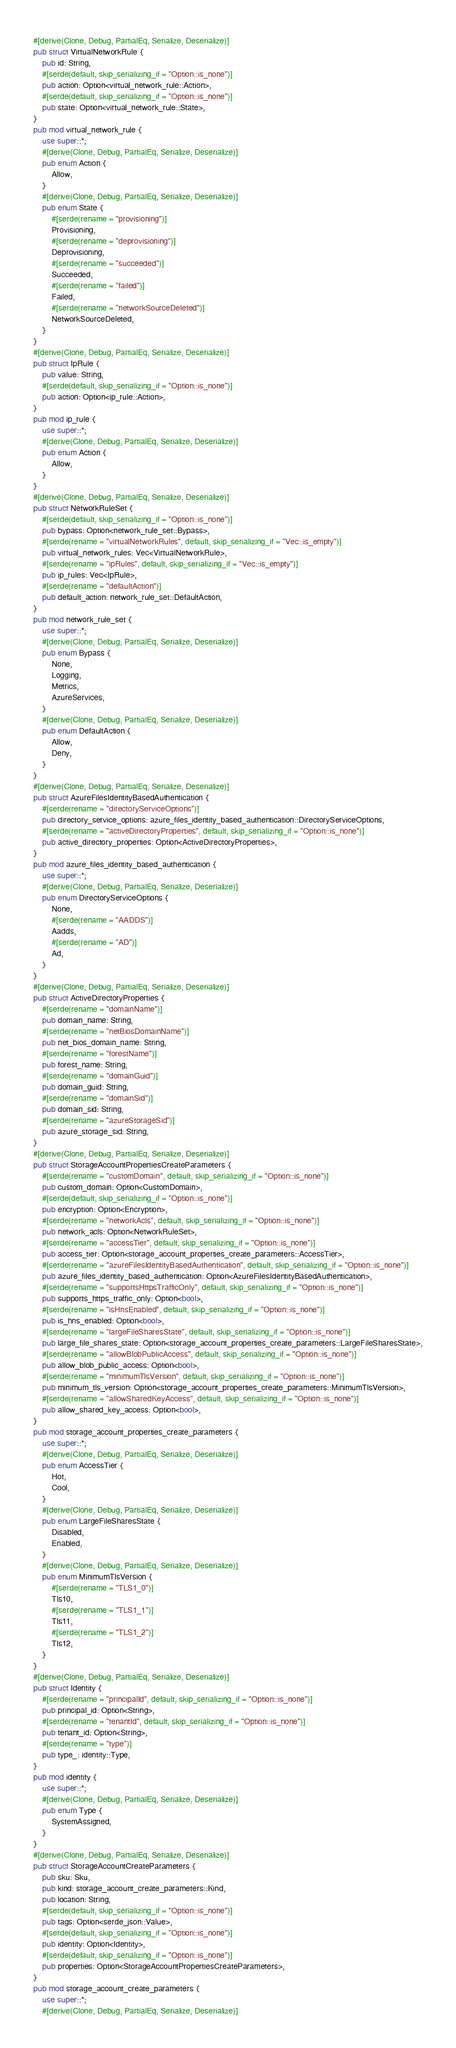Convert code to text. <code><loc_0><loc_0><loc_500><loc_500><_Rust_>#[derive(Clone, Debug, PartialEq, Serialize, Deserialize)]
pub struct VirtualNetworkRule {
    pub id: String,
    #[serde(default, skip_serializing_if = "Option::is_none")]
    pub action: Option<virtual_network_rule::Action>,
    #[serde(default, skip_serializing_if = "Option::is_none")]
    pub state: Option<virtual_network_rule::State>,
}
pub mod virtual_network_rule {
    use super::*;
    #[derive(Clone, Debug, PartialEq, Serialize, Deserialize)]
    pub enum Action {
        Allow,
    }
    #[derive(Clone, Debug, PartialEq, Serialize, Deserialize)]
    pub enum State {
        #[serde(rename = "provisioning")]
        Provisioning,
        #[serde(rename = "deprovisioning")]
        Deprovisioning,
        #[serde(rename = "succeeded")]
        Succeeded,
        #[serde(rename = "failed")]
        Failed,
        #[serde(rename = "networkSourceDeleted")]
        NetworkSourceDeleted,
    }
}
#[derive(Clone, Debug, PartialEq, Serialize, Deserialize)]
pub struct IpRule {
    pub value: String,
    #[serde(default, skip_serializing_if = "Option::is_none")]
    pub action: Option<ip_rule::Action>,
}
pub mod ip_rule {
    use super::*;
    #[derive(Clone, Debug, PartialEq, Serialize, Deserialize)]
    pub enum Action {
        Allow,
    }
}
#[derive(Clone, Debug, PartialEq, Serialize, Deserialize)]
pub struct NetworkRuleSet {
    #[serde(default, skip_serializing_if = "Option::is_none")]
    pub bypass: Option<network_rule_set::Bypass>,
    #[serde(rename = "virtualNetworkRules", default, skip_serializing_if = "Vec::is_empty")]
    pub virtual_network_rules: Vec<VirtualNetworkRule>,
    #[serde(rename = "ipRules", default, skip_serializing_if = "Vec::is_empty")]
    pub ip_rules: Vec<IpRule>,
    #[serde(rename = "defaultAction")]
    pub default_action: network_rule_set::DefaultAction,
}
pub mod network_rule_set {
    use super::*;
    #[derive(Clone, Debug, PartialEq, Serialize, Deserialize)]
    pub enum Bypass {
        None,
        Logging,
        Metrics,
        AzureServices,
    }
    #[derive(Clone, Debug, PartialEq, Serialize, Deserialize)]
    pub enum DefaultAction {
        Allow,
        Deny,
    }
}
#[derive(Clone, Debug, PartialEq, Serialize, Deserialize)]
pub struct AzureFilesIdentityBasedAuthentication {
    #[serde(rename = "directoryServiceOptions")]
    pub directory_service_options: azure_files_identity_based_authentication::DirectoryServiceOptions,
    #[serde(rename = "activeDirectoryProperties", default, skip_serializing_if = "Option::is_none")]
    pub active_directory_properties: Option<ActiveDirectoryProperties>,
}
pub mod azure_files_identity_based_authentication {
    use super::*;
    #[derive(Clone, Debug, PartialEq, Serialize, Deserialize)]
    pub enum DirectoryServiceOptions {
        None,
        #[serde(rename = "AADDS")]
        Aadds,
        #[serde(rename = "AD")]
        Ad,
    }
}
#[derive(Clone, Debug, PartialEq, Serialize, Deserialize)]
pub struct ActiveDirectoryProperties {
    #[serde(rename = "domainName")]
    pub domain_name: String,
    #[serde(rename = "netBiosDomainName")]
    pub net_bios_domain_name: String,
    #[serde(rename = "forestName")]
    pub forest_name: String,
    #[serde(rename = "domainGuid")]
    pub domain_guid: String,
    #[serde(rename = "domainSid")]
    pub domain_sid: String,
    #[serde(rename = "azureStorageSid")]
    pub azure_storage_sid: String,
}
#[derive(Clone, Debug, PartialEq, Serialize, Deserialize)]
pub struct StorageAccountPropertiesCreateParameters {
    #[serde(rename = "customDomain", default, skip_serializing_if = "Option::is_none")]
    pub custom_domain: Option<CustomDomain>,
    #[serde(default, skip_serializing_if = "Option::is_none")]
    pub encryption: Option<Encryption>,
    #[serde(rename = "networkAcls", default, skip_serializing_if = "Option::is_none")]
    pub network_acls: Option<NetworkRuleSet>,
    #[serde(rename = "accessTier", default, skip_serializing_if = "Option::is_none")]
    pub access_tier: Option<storage_account_properties_create_parameters::AccessTier>,
    #[serde(rename = "azureFilesIdentityBasedAuthentication", default, skip_serializing_if = "Option::is_none")]
    pub azure_files_identity_based_authentication: Option<AzureFilesIdentityBasedAuthentication>,
    #[serde(rename = "supportsHttpsTrafficOnly", default, skip_serializing_if = "Option::is_none")]
    pub supports_https_traffic_only: Option<bool>,
    #[serde(rename = "isHnsEnabled", default, skip_serializing_if = "Option::is_none")]
    pub is_hns_enabled: Option<bool>,
    #[serde(rename = "largeFileSharesState", default, skip_serializing_if = "Option::is_none")]
    pub large_file_shares_state: Option<storage_account_properties_create_parameters::LargeFileSharesState>,
    #[serde(rename = "allowBlobPublicAccess", default, skip_serializing_if = "Option::is_none")]
    pub allow_blob_public_access: Option<bool>,
    #[serde(rename = "minimumTlsVersion", default, skip_serializing_if = "Option::is_none")]
    pub minimum_tls_version: Option<storage_account_properties_create_parameters::MinimumTlsVersion>,
    #[serde(rename = "allowSharedKeyAccess", default, skip_serializing_if = "Option::is_none")]
    pub allow_shared_key_access: Option<bool>,
}
pub mod storage_account_properties_create_parameters {
    use super::*;
    #[derive(Clone, Debug, PartialEq, Serialize, Deserialize)]
    pub enum AccessTier {
        Hot,
        Cool,
    }
    #[derive(Clone, Debug, PartialEq, Serialize, Deserialize)]
    pub enum LargeFileSharesState {
        Disabled,
        Enabled,
    }
    #[derive(Clone, Debug, PartialEq, Serialize, Deserialize)]
    pub enum MinimumTlsVersion {
        #[serde(rename = "TLS1_0")]
        Tls10,
        #[serde(rename = "TLS1_1")]
        Tls11,
        #[serde(rename = "TLS1_2")]
        Tls12,
    }
}
#[derive(Clone, Debug, PartialEq, Serialize, Deserialize)]
pub struct Identity {
    #[serde(rename = "principalId", default, skip_serializing_if = "Option::is_none")]
    pub principal_id: Option<String>,
    #[serde(rename = "tenantId", default, skip_serializing_if = "Option::is_none")]
    pub tenant_id: Option<String>,
    #[serde(rename = "type")]
    pub type_: identity::Type,
}
pub mod identity {
    use super::*;
    #[derive(Clone, Debug, PartialEq, Serialize, Deserialize)]
    pub enum Type {
        SystemAssigned,
    }
}
#[derive(Clone, Debug, PartialEq, Serialize, Deserialize)]
pub struct StorageAccountCreateParameters {
    pub sku: Sku,
    pub kind: storage_account_create_parameters::Kind,
    pub location: String,
    #[serde(default, skip_serializing_if = "Option::is_none")]
    pub tags: Option<serde_json::Value>,
    #[serde(default, skip_serializing_if = "Option::is_none")]
    pub identity: Option<Identity>,
    #[serde(default, skip_serializing_if = "Option::is_none")]
    pub properties: Option<StorageAccountPropertiesCreateParameters>,
}
pub mod storage_account_create_parameters {
    use super::*;
    #[derive(Clone, Debug, PartialEq, Serialize, Deserialize)]</code> 